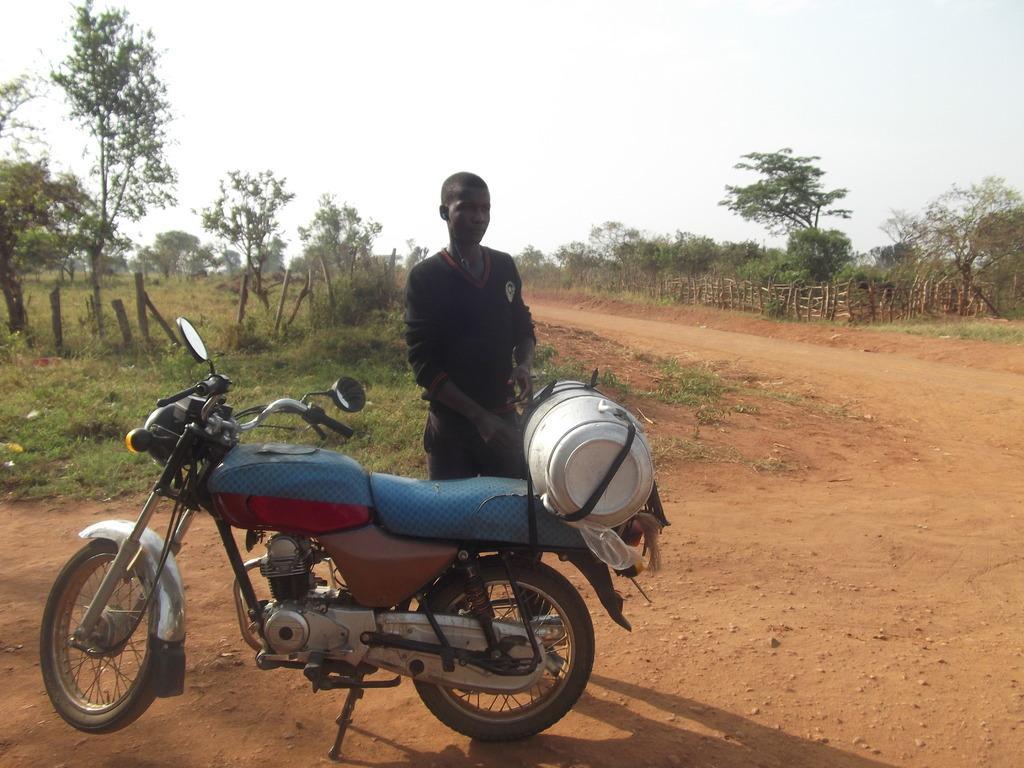Please provide a concise description of this image. In the image we can see a man standing and wearing clothes. In front of him there is a bike, this is an object, sand, grass, pole, plant, trees, wooden fence and a white sky. 